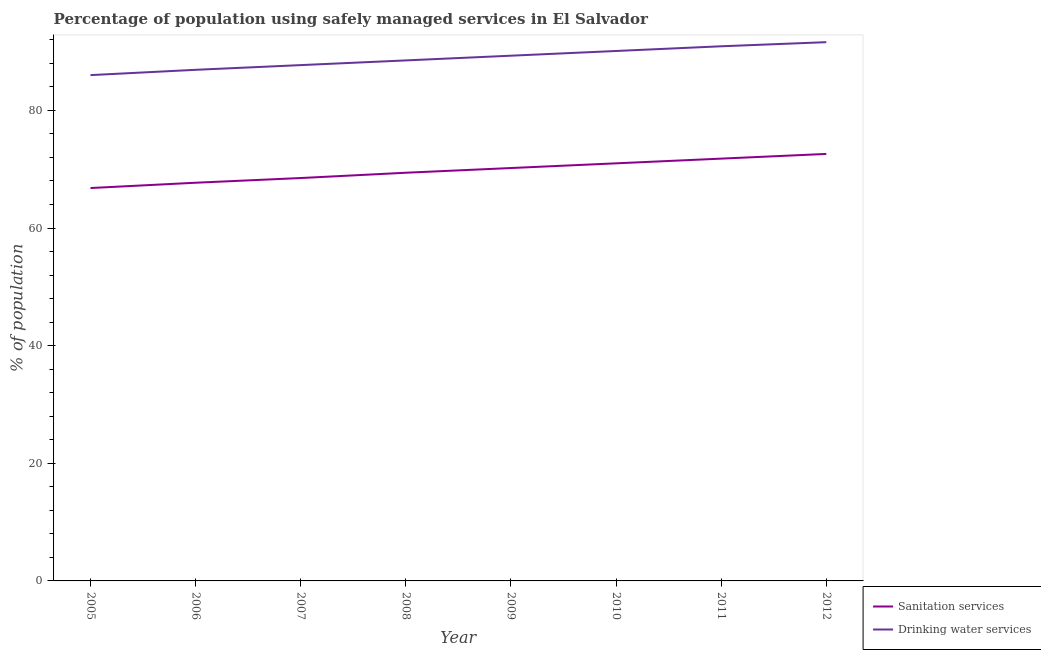How many different coloured lines are there?
Provide a short and direct response. 2. Does the line corresponding to percentage of population who used sanitation services intersect with the line corresponding to percentage of population who used drinking water services?
Offer a very short reply. No. What is the percentage of population who used drinking water services in 2011?
Provide a succinct answer. 90.9. Across all years, what is the maximum percentage of population who used sanitation services?
Your answer should be very brief. 72.6. In which year was the percentage of population who used drinking water services minimum?
Your response must be concise. 2005. What is the total percentage of population who used sanitation services in the graph?
Give a very brief answer. 558. What is the difference between the percentage of population who used sanitation services in 2008 and that in 2011?
Give a very brief answer. -2.4. What is the difference between the percentage of population who used drinking water services in 2012 and the percentage of population who used sanitation services in 2005?
Your answer should be very brief. 24.8. What is the average percentage of population who used sanitation services per year?
Provide a short and direct response. 69.75. In the year 2011, what is the difference between the percentage of population who used drinking water services and percentage of population who used sanitation services?
Offer a very short reply. 19.1. What is the ratio of the percentage of population who used sanitation services in 2006 to that in 2010?
Ensure brevity in your answer.  0.95. Is the percentage of population who used sanitation services in 2006 less than that in 2007?
Keep it short and to the point. Yes. What is the difference between the highest and the second highest percentage of population who used drinking water services?
Your response must be concise. 0.7. What is the difference between the highest and the lowest percentage of population who used drinking water services?
Offer a very short reply. 5.6. Is the sum of the percentage of population who used sanitation services in 2009 and 2012 greater than the maximum percentage of population who used drinking water services across all years?
Make the answer very short. Yes. How many years are there in the graph?
Make the answer very short. 8. What is the difference between two consecutive major ticks on the Y-axis?
Your answer should be very brief. 20. Are the values on the major ticks of Y-axis written in scientific E-notation?
Make the answer very short. No. Does the graph contain any zero values?
Offer a terse response. No. Where does the legend appear in the graph?
Make the answer very short. Bottom right. How many legend labels are there?
Your response must be concise. 2. How are the legend labels stacked?
Make the answer very short. Vertical. What is the title of the graph?
Offer a terse response. Percentage of population using safely managed services in El Salvador. What is the label or title of the Y-axis?
Provide a succinct answer. % of population. What is the % of population in Sanitation services in 2005?
Make the answer very short. 66.8. What is the % of population in Drinking water services in 2005?
Ensure brevity in your answer.  86. What is the % of population in Sanitation services in 2006?
Provide a succinct answer. 67.7. What is the % of population in Drinking water services in 2006?
Your answer should be very brief. 86.9. What is the % of population in Sanitation services in 2007?
Your response must be concise. 68.5. What is the % of population in Drinking water services in 2007?
Give a very brief answer. 87.7. What is the % of population in Sanitation services in 2008?
Make the answer very short. 69.4. What is the % of population of Drinking water services in 2008?
Offer a very short reply. 88.5. What is the % of population of Sanitation services in 2009?
Your answer should be very brief. 70.2. What is the % of population in Drinking water services in 2009?
Your answer should be very brief. 89.3. What is the % of population in Drinking water services in 2010?
Provide a short and direct response. 90.1. What is the % of population in Sanitation services in 2011?
Your answer should be compact. 71.8. What is the % of population of Drinking water services in 2011?
Your answer should be compact. 90.9. What is the % of population of Sanitation services in 2012?
Give a very brief answer. 72.6. What is the % of population in Drinking water services in 2012?
Ensure brevity in your answer.  91.6. Across all years, what is the maximum % of population of Sanitation services?
Make the answer very short. 72.6. Across all years, what is the maximum % of population in Drinking water services?
Your response must be concise. 91.6. Across all years, what is the minimum % of population of Sanitation services?
Ensure brevity in your answer.  66.8. Across all years, what is the minimum % of population of Drinking water services?
Give a very brief answer. 86. What is the total % of population in Sanitation services in the graph?
Make the answer very short. 558. What is the total % of population of Drinking water services in the graph?
Provide a succinct answer. 711. What is the difference between the % of population in Drinking water services in 2005 and that in 2007?
Your response must be concise. -1.7. What is the difference between the % of population of Sanitation services in 2005 and that in 2008?
Keep it short and to the point. -2.6. What is the difference between the % of population of Drinking water services in 2005 and that in 2008?
Your answer should be compact. -2.5. What is the difference between the % of population of Drinking water services in 2005 and that in 2009?
Provide a succinct answer. -3.3. What is the difference between the % of population of Drinking water services in 2005 and that in 2010?
Ensure brevity in your answer.  -4.1. What is the difference between the % of population in Sanitation services in 2005 and that in 2012?
Ensure brevity in your answer.  -5.8. What is the difference between the % of population of Drinking water services in 2005 and that in 2012?
Provide a succinct answer. -5.6. What is the difference between the % of population in Drinking water services in 2006 and that in 2007?
Keep it short and to the point. -0.8. What is the difference between the % of population of Sanitation services in 2006 and that in 2008?
Provide a short and direct response. -1.7. What is the difference between the % of population in Drinking water services in 2006 and that in 2008?
Offer a very short reply. -1.6. What is the difference between the % of population in Sanitation services in 2006 and that in 2009?
Make the answer very short. -2.5. What is the difference between the % of population in Drinking water services in 2006 and that in 2009?
Your answer should be compact. -2.4. What is the difference between the % of population of Drinking water services in 2006 and that in 2010?
Ensure brevity in your answer.  -3.2. What is the difference between the % of population in Sanitation services in 2006 and that in 2011?
Provide a succinct answer. -4.1. What is the difference between the % of population in Drinking water services in 2006 and that in 2012?
Offer a very short reply. -4.7. What is the difference between the % of population of Sanitation services in 2007 and that in 2008?
Your answer should be very brief. -0.9. What is the difference between the % of population of Sanitation services in 2007 and that in 2009?
Your answer should be compact. -1.7. What is the difference between the % of population in Drinking water services in 2007 and that in 2009?
Your response must be concise. -1.6. What is the difference between the % of population of Drinking water services in 2007 and that in 2010?
Make the answer very short. -2.4. What is the difference between the % of population in Sanitation services in 2007 and that in 2011?
Your answer should be very brief. -3.3. What is the difference between the % of population of Sanitation services in 2007 and that in 2012?
Your answer should be compact. -4.1. What is the difference between the % of population in Drinking water services in 2007 and that in 2012?
Make the answer very short. -3.9. What is the difference between the % of population of Sanitation services in 2008 and that in 2009?
Make the answer very short. -0.8. What is the difference between the % of population in Sanitation services in 2008 and that in 2010?
Your response must be concise. -1.6. What is the difference between the % of population in Sanitation services in 2008 and that in 2011?
Offer a very short reply. -2.4. What is the difference between the % of population in Sanitation services in 2008 and that in 2012?
Provide a succinct answer. -3.2. What is the difference between the % of population in Drinking water services in 2008 and that in 2012?
Offer a terse response. -3.1. What is the difference between the % of population of Drinking water services in 2009 and that in 2011?
Give a very brief answer. -1.6. What is the difference between the % of population of Sanitation services in 2009 and that in 2012?
Provide a short and direct response. -2.4. What is the difference between the % of population in Sanitation services in 2010 and that in 2011?
Your answer should be very brief. -0.8. What is the difference between the % of population in Sanitation services in 2010 and that in 2012?
Keep it short and to the point. -1.6. What is the difference between the % of population of Drinking water services in 2010 and that in 2012?
Provide a short and direct response. -1.5. What is the difference between the % of population of Sanitation services in 2005 and the % of population of Drinking water services in 2006?
Your response must be concise. -20.1. What is the difference between the % of population in Sanitation services in 2005 and the % of population in Drinking water services in 2007?
Make the answer very short. -20.9. What is the difference between the % of population in Sanitation services in 2005 and the % of population in Drinking water services in 2008?
Offer a very short reply. -21.7. What is the difference between the % of population in Sanitation services in 2005 and the % of population in Drinking water services in 2009?
Your answer should be compact. -22.5. What is the difference between the % of population of Sanitation services in 2005 and the % of population of Drinking water services in 2010?
Your answer should be very brief. -23.3. What is the difference between the % of population of Sanitation services in 2005 and the % of population of Drinking water services in 2011?
Give a very brief answer. -24.1. What is the difference between the % of population in Sanitation services in 2005 and the % of population in Drinking water services in 2012?
Your answer should be compact. -24.8. What is the difference between the % of population of Sanitation services in 2006 and the % of population of Drinking water services in 2008?
Make the answer very short. -20.8. What is the difference between the % of population in Sanitation services in 2006 and the % of population in Drinking water services in 2009?
Your response must be concise. -21.6. What is the difference between the % of population in Sanitation services in 2006 and the % of population in Drinking water services in 2010?
Your answer should be very brief. -22.4. What is the difference between the % of population in Sanitation services in 2006 and the % of population in Drinking water services in 2011?
Ensure brevity in your answer.  -23.2. What is the difference between the % of population in Sanitation services in 2006 and the % of population in Drinking water services in 2012?
Your answer should be compact. -23.9. What is the difference between the % of population in Sanitation services in 2007 and the % of population in Drinking water services in 2008?
Offer a terse response. -20. What is the difference between the % of population in Sanitation services in 2007 and the % of population in Drinking water services in 2009?
Keep it short and to the point. -20.8. What is the difference between the % of population of Sanitation services in 2007 and the % of population of Drinking water services in 2010?
Your answer should be very brief. -21.6. What is the difference between the % of population of Sanitation services in 2007 and the % of population of Drinking water services in 2011?
Your response must be concise. -22.4. What is the difference between the % of population of Sanitation services in 2007 and the % of population of Drinking water services in 2012?
Make the answer very short. -23.1. What is the difference between the % of population in Sanitation services in 2008 and the % of population in Drinking water services in 2009?
Ensure brevity in your answer.  -19.9. What is the difference between the % of population in Sanitation services in 2008 and the % of population in Drinking water services in 2010?
Ensure brevity in your answer.  -20.7. What is the difference between the % of population of Sanitation services in 2008 and the % of population of Drinking water services in 2011?
Your response must be concise. -21.5. What is the difference between the % of population in Sanitation services in 2008 and the % of population in Drinking water services in 2012?
Your answer should be very brief. -22.2. What is the difference between the % of population in Sanitation services in 2009 and the % of population in Drinking water services in 2010?
Give a very brief answer. -19.9. What is the difference between the % of population of Sanitation services in 2009 and the % of population of Drinking water services in 2011?
Give a very brief answer. -20.7. What is the difference between the % of population in Sanitation services in 2009 and the % of population in Drinking water services in 2012?
Offer a terse response. -21.4. What is the difference between the % of population in Sanitation services in 2010 and the % of population in Drinking water services in 2011?
Your answer should be compact. -19.9. What is the difference between the % of population of Sanitation services in 2010 and the % of population of Drinking water services in 2012?
Offer a terse response. -20.6. What is the difference between the % of population in Sanitation services in 2011 and the % of population in Drinking water services in 2012?
Offer a terse response. -19.8. What is the average % of population in Sanitation services per year?
Provide a short and direct response. 69.75. What is the average % of population in Drinking water services per year?
Provide a short and direct response. 88.88. In the year 2005, what is the difference between the % of population in Sanitation services and % of population in Drinking water services?
Give a very brief answer. -19.2. In the year 2006, what is the difference between the % of population in Sanitation services and % of population in Drinking water services?
Keep it short and to the point. -19.2. In the year 2007, what is the difference between the % of population of Sanitation services and % of population of Drinking water services?
Offer a terse response. -19.2. In the year 2008, what is the difference between the % of population of Sanitation services and % of population of Drinking water services?
Give a very brief answer. -19.1. In the year 2009, what is the difference between the % of population in Sanitation services and % of population in Drinking water services?
Your answer should be very brief. -19.1. In the year 2010, what is the difference between the % of population in Sanitation services and % of population in Drinking water services?
Ensure brevity in your answer.  -19.1. In the year 2011, what is the difference between the % of population of Sanitation services and % of population of Drinking water services?
Make the answer very short. -19.1. In the year 2012, what is the difference between the % of population in Sanitation services and % of population in Drinking water services?
Provide a short and direct response. -19. What is the ratio of the % of population of Sanitation services in 2005 to that in 2006?
Your answer should be very brief. 0.99. What is the ratio of the % of population in Sanitation services in 2005 to that in 2007?
Provide a succinct answer. 0.98. What is the ratio of the % of population of Drinking water services in 2005 to that in 2007?
Offer a terse response. 0.98. What is the ratio of the % of population in Sanitation services in 2005 to that in 2008?
Your answer should be very brief. 0.96. What is the ratio of the % of population in Drinking water services in 2005 to that in 2008?
Your answer should be very brief. 0.97. What is the ratio of the % of population of Sanitation services in 2005 to that in 2009?
Give a very brief answer. 0.95. What is the ratio of the % of population in Sanitation services in 2005 to that in 2010?
Provide a short and direct response. 0.94. What is the ratio of the % of population of Drinking water services in 2005 to that in 2010?
Make the answer very short. 0.95. What is the ratio of the % of population in Sanitation services in 2005 to that in 2011?
Offer a terse response. 0.93. What is the ratio of the % of population of Drinking water services in 2005 to that in 2011?
Ensure brevity in your answer.  0.95. What is the ratio of the % of population of Sanitation services in 2005 to that in 2012?
Provide a short and direct response. 0.92. What is the ratio of the % of population in Drinking water services in 2005 to that in 2012?
Make the answer very short. 0.94. What is the ratio of the % of population of Sanitation services in 2006 to that in 2007?
Offer a very short reply. 0.99. What is the ratio of the % of population in Drinking water services in 2006 to that in 2007?
Make the answer very short. 0.99. What is the ratio of the % of population in Sanitation services in 2006 to that in 2008?
Offer a terse response. 0.98. What is the ratio of the % of population of Drinking water services in 2006 to that in 2008?
Keep it short and to the point. 0.98. What is the ratio of the % of population of Sanitation services in 2006 to that in 2009?
Make the answer very short. 0.96. What is the ratio of the % of population in Drinking water services in 2006 to that in 2009?
Offer a terse response. 0.97. What is the ratio of the % of population in Sanitation services in 2006 to that in 2010?
Offer a very short reply. 0.95. What is the ratio of the % of population in Drinking water services in 2006 to that in 2010?
Make the answer very short. 0.96. What is the ratio of the % of population of Sanitation services in 2006 to that in 2011?
Give a very brief answer. 0.94. What is the ratio of the % of population in Drinking water services in 2006 to that in 2011?
Give a very brief answer. 0.96. What is the ratio of the % of population of Sanitation services in 2006 to that in 2012?
Offer a very short reply. 0.93. What is the ratio of the % of population of Drinking water services in 2006 to that in 2012?
Offer a terse response. 0.95. What is the ratio of the % of population in Sanitation services in 2007 to that in 2009?
Keep it short and to the point. 0.98. What is the ratio of the % of population in Drinking water services in 2007 to that in 2009?
Offer a very short reply. 0.98. What is the ratio of the % of population of Sanitation services in 2007 to that in 2010?
Make the answer very short. 0.96. What is the ratio of the % of population in Drinking water services in 2007 to that in 2010?
Give a very brief answer. 0.97. What is the ratio of the % of population in Sanitation services in 2007 to that in 2011?
Make the answer very short. 0.95. What is the ratio of the % of population in Drinking water services in 2007 to that in 2011?
Give a very brief answer. 0.96. What is the ratio of the % of population in Sanitation services in 2007 to that in 2012?
Provide a short and direct response. 0.94. What is the ratio of the % of population of Drinking water services in 2007 to that in 2012?
Your response must be concise. 0.96. What is the ratio of the % of population in Drinking water services in 2008 to that in 2009?
Provide a succinct answer. 0.99. What is the ratio of the % of population in Sanitation services in 2008 to that in 2010?
Your answer should be very brief. 0.98. What is the ratio of the % of population of Drinking water services in 2008 to that in 2010?
Give a very brief answer. 0.98. What is the ratio of the % of population in Sanitation services in 2008 to that in 2011?
Offer a very short reply. 0.97. What is the ratio of the % of population of Drinking water services in 2008 to that in 2011?
Give a very brief answer. 0.97. What is the ratio of the % of population of Sanitation services in 2008 to that in 2012?
Make the answer very short. 0.96. What is the ratio of the % of population in Drinking water services in 2008 to that in 2012?
Offer a very short reply. 0.97. What is the ratio of the % of population of Sanitation services in 2009 to that in 2010?
Keep it short and to the point. 0.99. What is the ratio of the % of population in Sanitation services in 2009 to that in 2011?
Offer a terse response. 0.98. What is the ratio of the % of population in Drinking water services in 2009 to that in 2011?
Offer a very short reply. 0.98. What is the ratio of the % of population of Sanitation services in 2009 to that in 2012?
Provide a short and direct response. 0.97. What is the ratio of the % of population of Drinking water services in 2009 to that in 2012?
Provide a succinct answer. 0.97. What is the ratio of the % of population in Sanitation services in 2010 to that in 2011?
Keep it short and to the point. 0.99. What is the ratio of the % of population in Drinking water services in 2010 to that in 2012?
Make the answer very short. 0.98. What is the ratio of the % of population of Sanitation services in 2011 to that in 2012?
Provide a short and direct response. 0.99. 